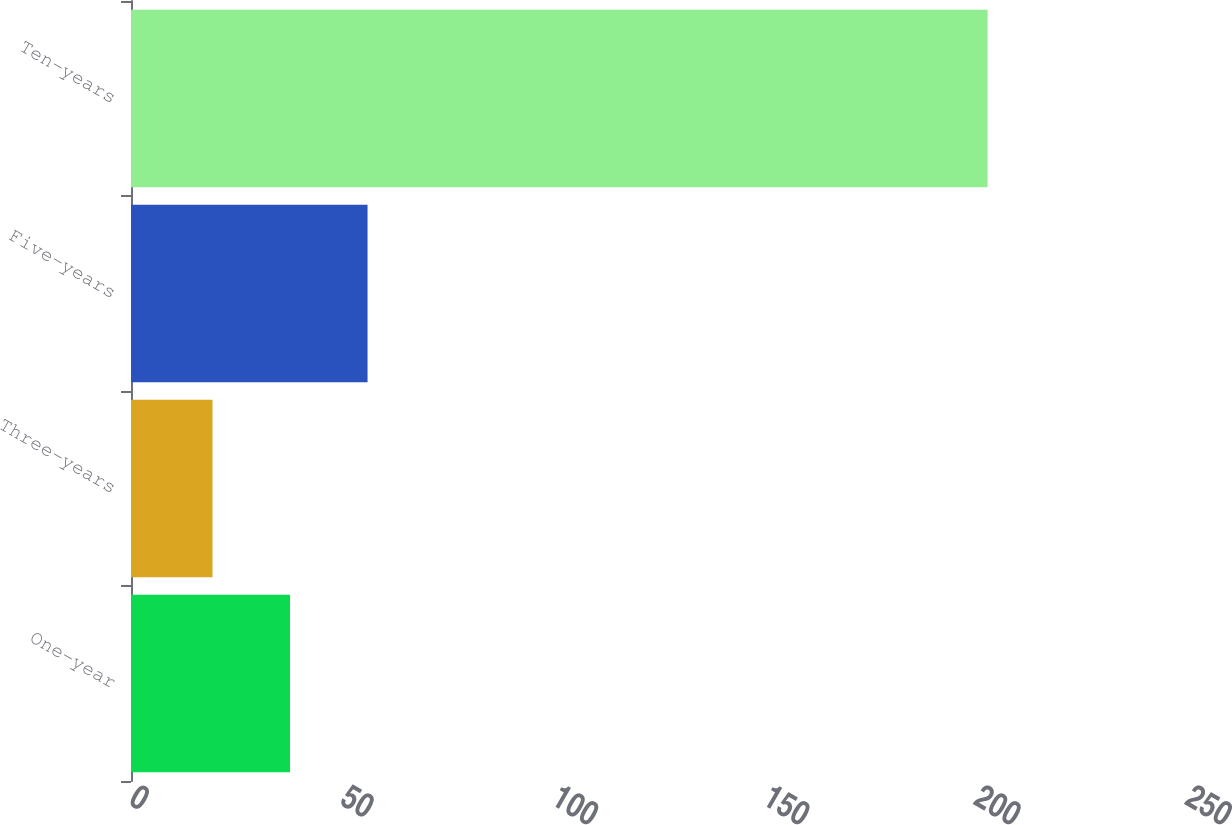Convert chart to OTSL. <chart><loc_0><loc_0><loc_500><loc_500><bar_chart><fcel>One-year<fcel>Three-years<fcel>Five-years<fcel>Ten-years<nl><fcel>37.65<fcel>19.3<fcel>56<fcel>202.8<nl></chart> 